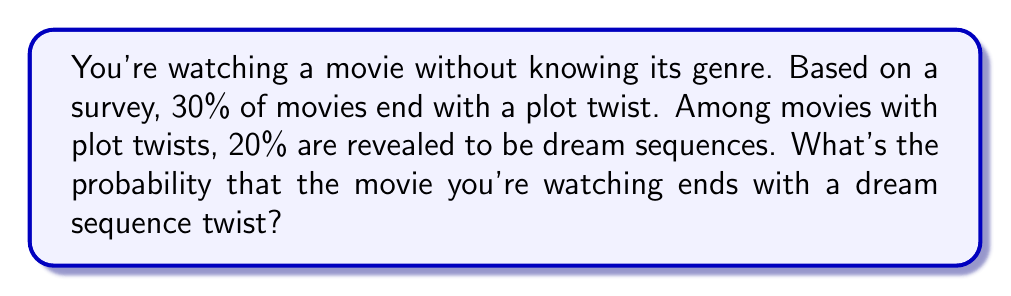Show me your answer to this math problem. Let's approach this step-by-step:

1) Let's define our events:
   A: The movie ends with a plot twist
   B: The movie ends with a dream sequence twist

2) We're given:
   $P(A) = 0.30$ (30% of movies end with a plot twist)
   $P(B|A) = 0.20$ (20% of movies with plot twists are dream sequences)

3) We want to find $P(B)$, the probability that the movie ends with a dream sequence twist.

4) We can use the law of total probability:
   $P(B) = P(B|A) \cdot P(A) + P(B|\text{not }A) \cdot P(\text{not }A)$

5) We know $P(B|A)$ and $P(A)$. We also know that if there's no plot twist, there can't be a dream sequence twist, so $P(B|\text{not }A) = 0$.

6) Let's calculate:
   $P(B) = 0.20 \cdot 0.30 + 0 \cdot 0.70 = 0.06$

Therefore, the probability that the movie ends with a dream sequence twist is 0.06 or 6%.
Answer: 0.06 